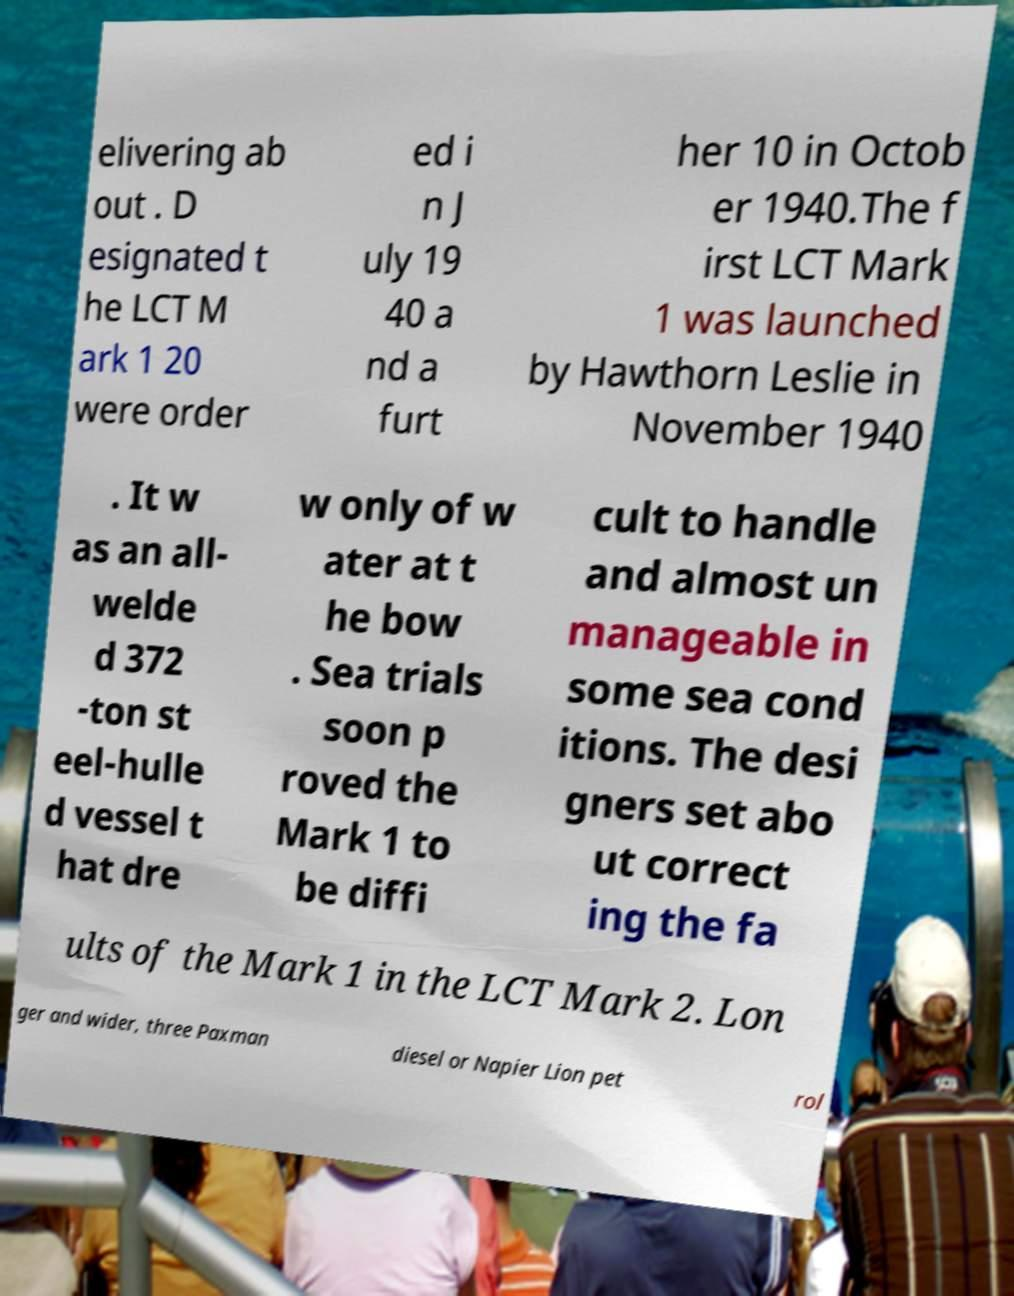What messages or text are displayed in this image? I need them in a readable, typed format. elivering ab out . D esignated t he LCT M ark 1 20 were order ed i n J uly 19 40 a nd a furt her 10 in Octob er 1940.The f irst LCT Mark 1 was launched by Hawthorn Leslie in November 1940 . It w as an all- welde d 372 -ton st eel-hulle d vessel t hat dre w only of w ater at t he bow . Sea trials soon p roved the Mark 1 to be diffi cult to handle and almost un manageable in some sea cond itions. The desi gners set abo ut correct ing the fa ults of the Mark 1 in the LCT Mark 2. Lon ger and wider, three Paxman diesel or Napier Lion pet rol 